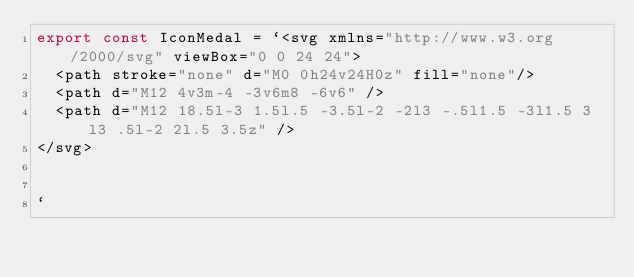<code> <loc_0><loc_0><loc_500><loc_500><_TypeScript_>export const IconMedal = `<svg xmlns="http://www.w3.org/2000/svg" viewBox="0 0 24 24">
  <path stroke="none" d="M0 0h24v24H0z" fill="none"/>
  <path d="M12 4v3m-4 -3v6m8 -6v6" />
  <path d="M12 18.5l-3 1.5l.5 -3.5l-2 -2l3 -.5l1.5 -3l1.5 3l3 .5l-2 2l.5 3.5z" />
</svg>


`</code> 